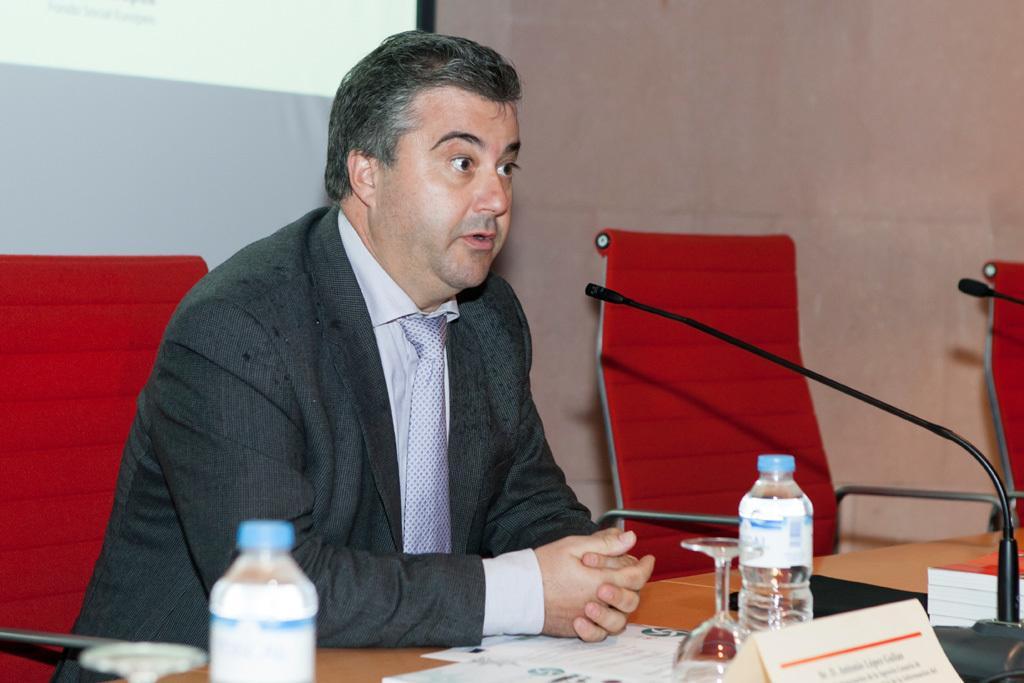Can you describe this image briefly? This picture shows a man sitting in the red color chair in front of a table on which some papers, glasses, water bottles, name plates and a mic were placed. In the background there is a wall and a projector display screen. 